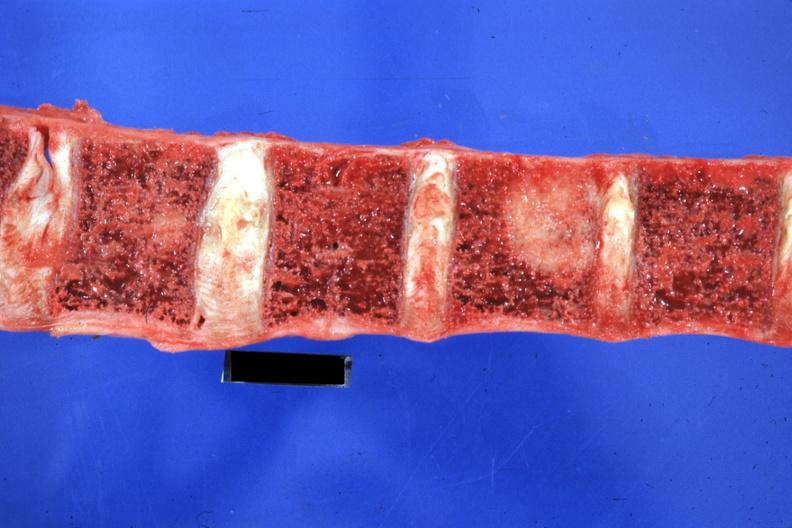does this image show easily seen large lesion primary in tail of pancreas?
Answer the question using a single word or phrase. Yes 